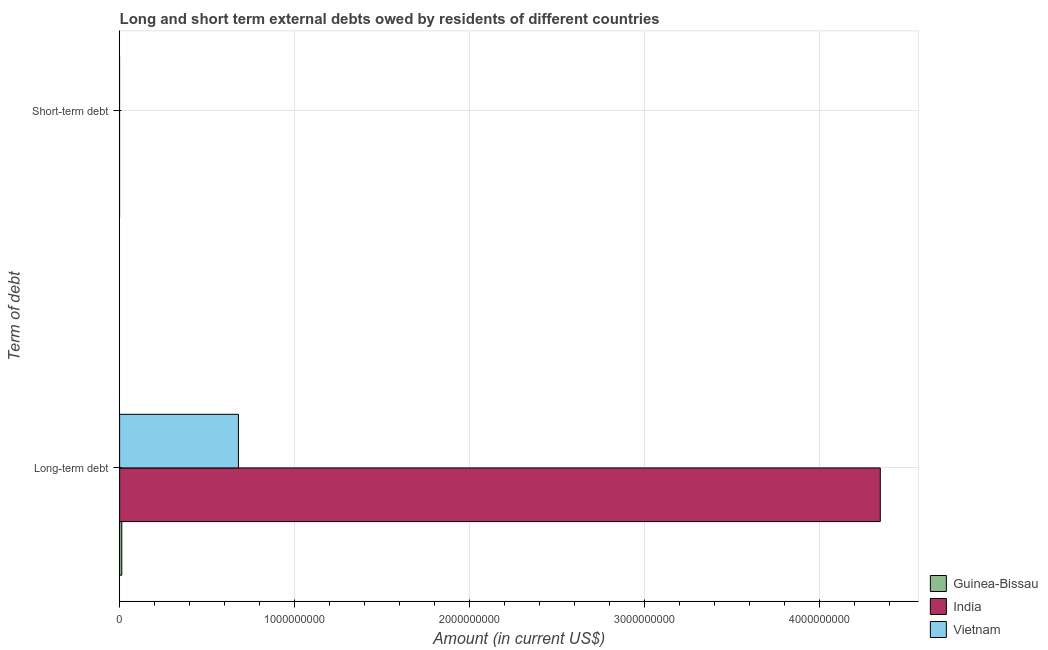How many different coloured bars are there?
Ensure brevity in your answer.  3. Are the number of bars per tick equal to the number of legend labels?
Your response must be concise. No. How many bars are there on the 2nd tick from the bottom?
Make the answer very short. 0. What is the label of the 2nd group of bars from the top?
Provide a succinct answer. Long-term debt. Across all countries, what is the maximum long-term debts owed by residents?
Ensure brevity in your answer.  4.34e+09. Across all countries, what is the minimum long-term debts owed by residents?
Offer a terse response. 1.25e+07. In which country was the long-term debts owed by residents maximum?
Ensure brevity in your answer.  India. What is the total short-term debts owed by residents in the graph?
Provide a succinct answer. 0. What is the difference between the long-term debts owed by residents in India and that in Guinea-Bissau?
Ensure brevity in your answer.  4.33e+09. What is the difference between the long-term debts owed by residents in Guinea-Bissau and the short-term debts owed by residents in India?
Your answer should be very brief. 1.25e+07. In how many countries, is the short-term debts owed by residents greater than 400000000 US$?
Keep it short and to the point. 0. What is the ratio of the long-term debts owed by residents in Vietnam to that in India?
Your answer should be very brief. 0.16. In how many countries, is the short-term debts owed by residents greater than the average short-term debts owed by residents taken over all countries?
Offer a terse response. 0. Are all the bars in the graph horizontal?
Provide a short and direct response. Yes. What is the difference between two consecutive major ticks on the X-axis?
Provide a short and direct response. 1.00e+09. Does the graph contain any zero values?
Offer a terse response. Yes. Does the graph contain grids?
Offer a very short reply. Yes. Where does the legend appear in the graph?
Offer a terse response. Bottom right. What is the title of the graph?
Your answer should be very brief. Long and short term external debts owed by residents of different countries. What is the label or title of the X-axis?
Your response must be concise. Amount (in current US$). What is the label or title of the Y-axis?
Keep it short and to the point. Term of debt. What is the Amount (in current US$) of Guinea-Bissau in Long-term debt?
Give a very brief answer. 1.25e+07. What is the Amount (in current US$) of India in Long-term debt?
Make the answer very short. 4.34e+09. What is the Amount (in current US$) of Vietnam in Long-term debt?
Keep it short and to the point. 6.79e+08. What is the Amount (in current US$) of Guinea-Bissau in Short-term debt?
Offer a very short reply. 0. What is the Amount (in current US$) of Vietnam in Short-term debt?
Make the answer very short. 0. Across all Term of debt, what is the maximum Amount (in current US$) of Guinea-Bissau?
Offer a very short reply. 1.25e+07. Across all Term of debt, what is the maximum Amount (in current US$) of India?
Make the answer very short. 4.34e+09. Across all Term of debt, what is the maximum Amount (in current US$) of Vietnam?
Make the answer very short. 6.79e+08. Across all Term of debt, what is the minimum Amount (in current US$) of Guinea-Bissau?
Offer a terse response. 0. What is the total Amount (in current US$) of Guinea-Bissau in the graph?
Keep it short and to the point. 1.25e+07. What is the total Amount (in current US$) in India in the graph?
Ensure brevity in your answer.  4.34e+09. What is the total Amount (in current US$) in Vietnam in the graph?
Offer a very short reply. 6.79e+08. What is the average Amount (in current US$) of Guinea-Bissau per Term of debt?
Ensure brevity in your answer.  6.23e+06. What is the average Amount (in current US$) in India per Term of debt?
Give a very brief answer. 2.17e+09. What is the average Amount (in current US$) in Vietnam per Term of debt?
Offer a terse response. 3.39e+08. What is the difference between the Amount (in current US$) of Guinea-Bissau and Amount (in current US$) of India in Long-term debt?
Ensure brevity in your answer.  -4.33e+09. What is the difference between the Amount (in current US$) of Guinea-Bissau and Amount (in current US$) of Vietnam in Long-term debt?
Provide a short and direct response. -6.66e+08. What is the difference between the Amount (in current US$) of India and Amount (in current US$) of Vietnam in Long-term debt?
Your answer should be very brief. 3.67e+09. What is the difference between the highest and the lowest Amount (in current US$) in Guinea-Bissau?
Provide a short and direct response. 1.25e+07. What is the difference between the highest and the lowest Amount (in current US$) of India?
Offer a terse response. 4.34e+09. What is the difference between the highest and the lowest Amount (in current US$) in Vietnam?
Ensure brevity in your answer.  6.79e+08. 